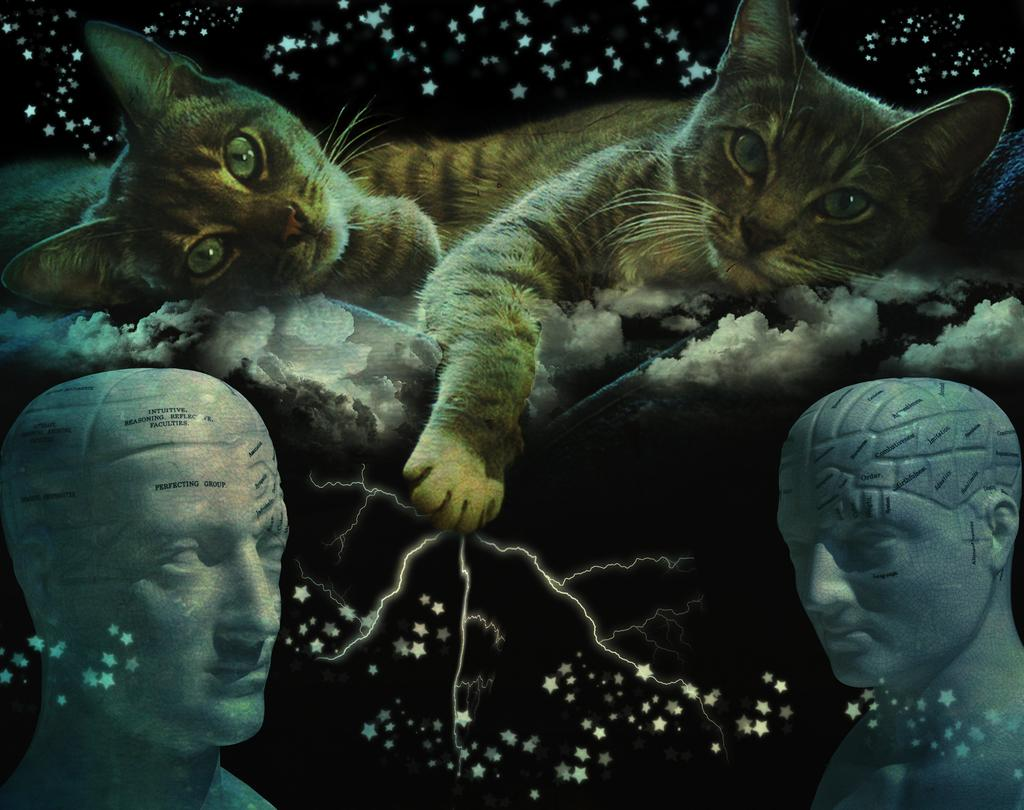What type of animals can be seen in the image? There are cats in the image. What other objects or structures are present in the image? There are statues and some objects in the image. Can you describe the background of the image? The background of the image is dark. What type of hope can be seen growing near the lake in the image? There is no lake, hope, or any type of plant growth mentioned in the image. 